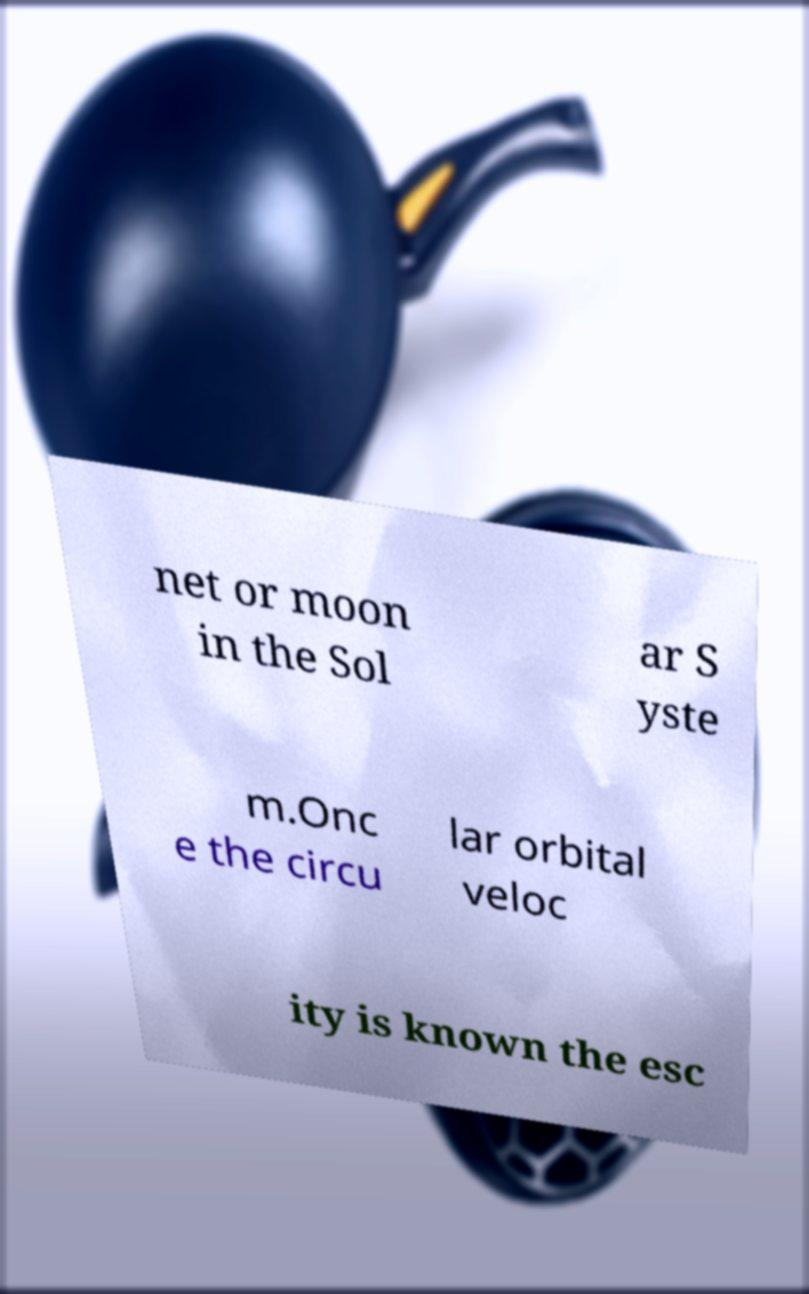I need the written content from this picture converted into text. Can you do that? net or moon in the Sol ar S yste m.Onc e the circu lar orbital veloc ity is known the esc 